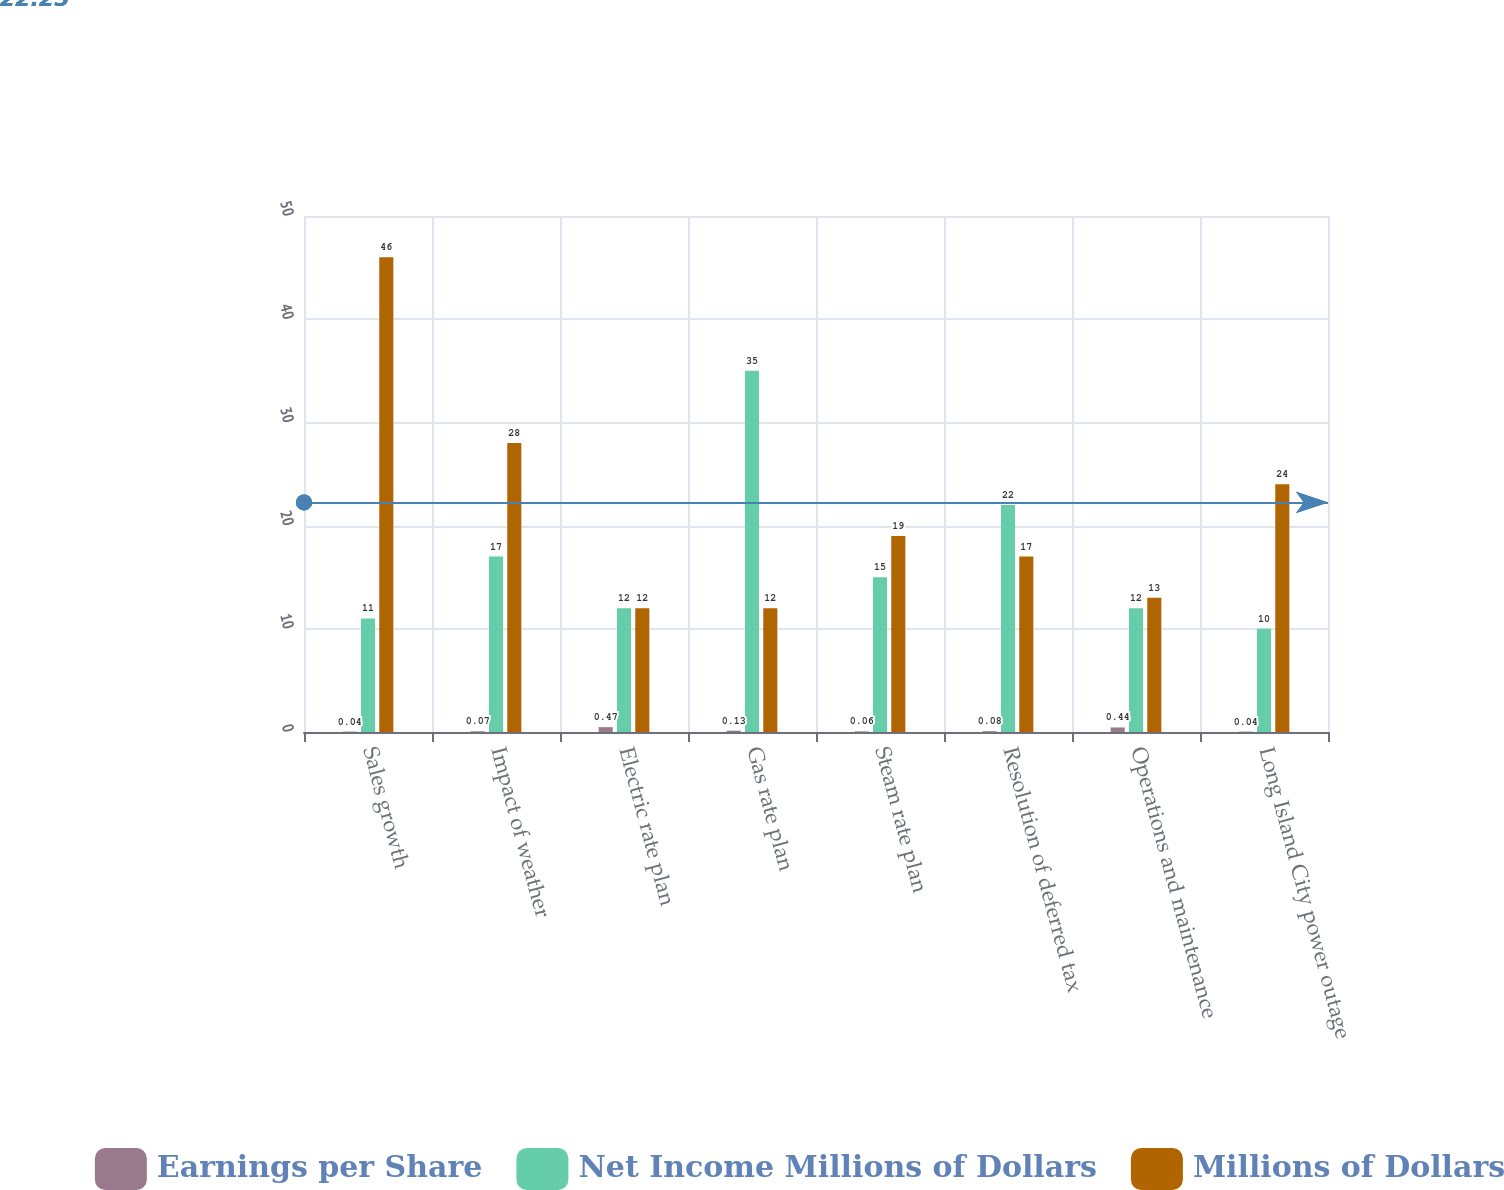Convert chart to OTSL. <chart><loc_0><loc_0><loc_500><loc_500><stacked_bar_chart><ecel><fcel>Sales growth<fcel>Impact of weather<fcel>Electric rate plan<fcel>Gas rate plan<fcel>Steam rate plan<fcel>Resolution of deferred tax<fcel>Operations and maintenance<fcel>Long Island City power outage<nl><fcel>Earnings per Share<fcel>0.04<fcel>0.07<fcel>0.47<fcel>0.13<fcel>0.06<fcel>0.08<fcel>0.44<fcel>0.04<nl><fcel>Net Income Millions of Dollars<fcel>11<fcel>17<fcel>12<fcel>35<fcel>15<fcel>22<fcel>12<fcel>10<nl><fcel>Millions of Dollars<fcel>46<fcel>28<fcel>12<fcel>12<fcel>19<fcel>17<fcel>13<fcel>24<nl></chart> 